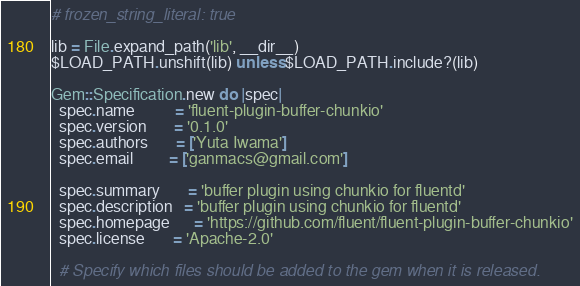Convert code to text. <code><loc_0><loc_0><loc_500><loc_500><_Ruby_># frozen_string_literal: true

lib = File.expand_path('lib', __dir__)
$LOAD_PATH.unshift(lib) unless $LOAD_PATH.include?(lib)

Gem::Specification.new do |spec|
  spec.name          = 'fluent-plugin-buffer-chunkio'
  spec.version       = '0.1.0'
  spec.authors       = ['Yuta Iwama']
  spec.email         = ['ganmacs@gmail.com']

  spec.summary       = 'buffer plugin using chunkio for fluentd'
  spec.description   = 'buffer plugin using chunkio for fluentd'
  spec.homepage      = 'https://github.com/fluent/fluent-plugin-buffer-chunkio'
  spec.license       = 'Apache-2.0'

  # Specify which files should be added to the gem when it is released.</code> 